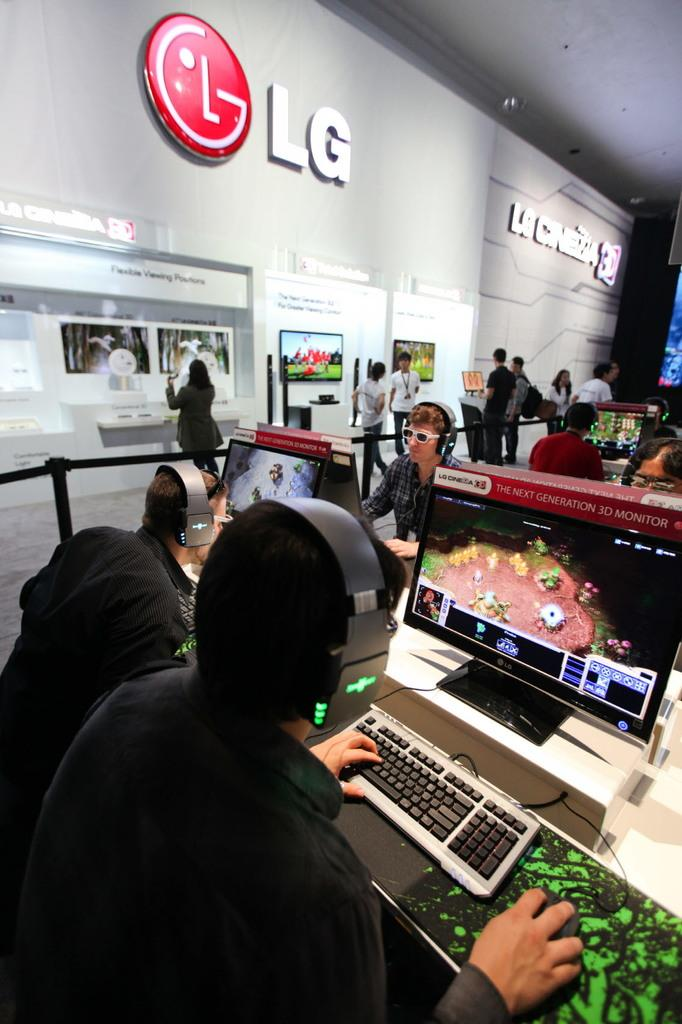What are the people in the image doing? The people are sitting and playing games on a computer screen. Can you describe the people in the background of the image? The standing people in the background are looking at an "LG" naming board. What might the people sitting be using to interact with the computer screen? The people sitting might be using a mouse or keyboard to interact with the computer screen. What type of mitten is being used to control the kite in the image? There is no mitten or kite present in the image. How many people are shaking hands in the image? There is no indication of people shaking hands in the image. 